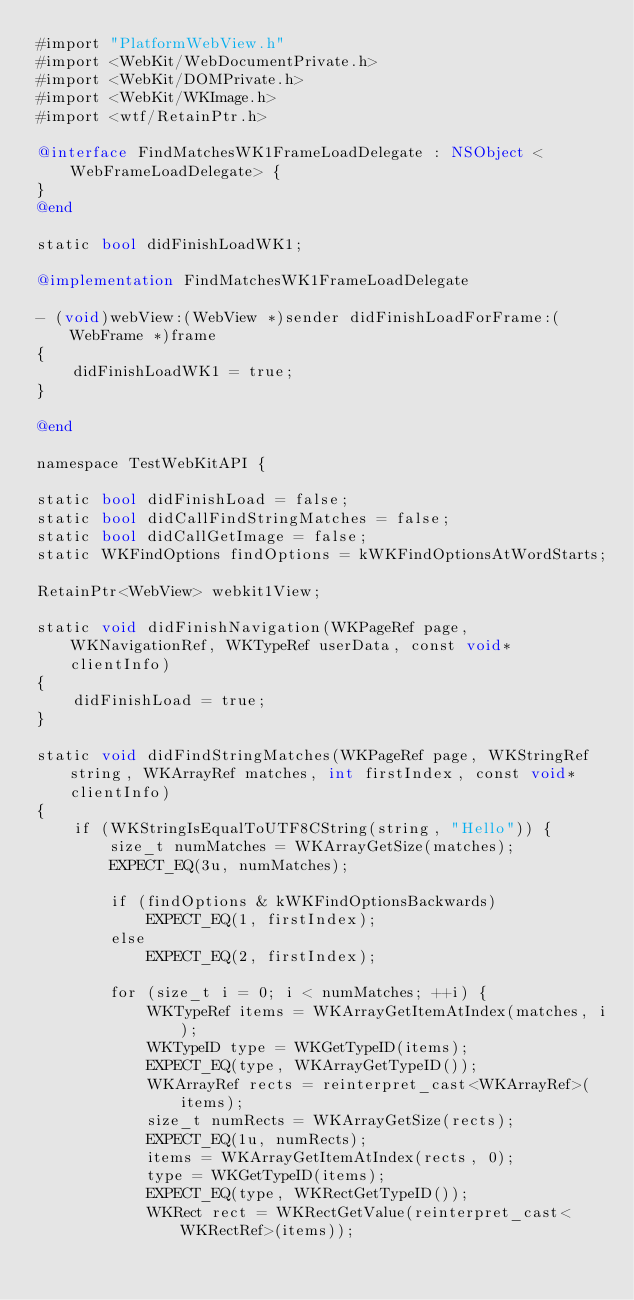<code> <loc_0><loc_0><loc_500><loc_500><_ObjectiveC_>#import "PlatformWebView.h"
#import <WebKit/WebDocumentPrivate.h>
#import <WebKit/DOMPrivate.h>
#import <WebKit/WKImage.h>
#import <wtf/RetainPtr.h>

@interface FindMatchesWK1FrameLoadDelegate : NSObject <WebFrameLoadDelegate> {
}
@end

static bool didFinishLoadWK1;

@implementation FindMatchesWK1FrameLoadDelegate

- (void)webView:(WebView *)sender didFinishLoadForFrame:(WebFrame *)frame
{
    didFinishLoadWK1 = true;
}

@end

namespace TestWebKitAPI {

static bool didFinishLoad = false;
static bool didCallFindStringMatches = false;
static bool didCallGetImage = false;
static WKFindOptions findOptions = kWKFindOptionsAtWordStarts;

RetainPtr<WebView> webkit1View;

static void didFinishNavigation(WKPageRef page, WKNavigationRef, WKTypeRef userData, const void* clientInfo)
{
    didFinishLoad = true;
}

static void didFindStringMatches(WKPageRef page, WKStringRef string, WKArrayRef matches, int firstIndex, const void* clientInfo)
{
    if (WKStringIsEqualToUTF8CString(string, "Hello")) {
        size_t numMatches = WKArrayGetSize(matches);
        EXPECT_EQ(3u, numMatches);

        if (findOptions & kWKFindOptionsBackwards)
            EXPECT_EQ(1, firstIndex);
        else
            EXPECT_EQ(2, firstIndex);

        for (size_t i = 0; i < numMatches; ++i) {
            WKTypeRef items = WKArrayGetItemAtIndex(matches, i);
            WKTypeID type = WKGetTypeID(items);
            EXPECT_EQ(type, WKArrayGetTypeID());
            WKArrayRef rects = reinterpret_cast<WKArrayRef>(items);
            size_t numRects = WKArrayGetSize(rects);
            EXPECT_EQ(1u, numRects);
            items = WKArrayGetItemAtIndex(rects, 0);
            type = WKGetTypeID(items);
            EXPECT_EQ(type, WKRectGetTypeID());
            WKRect rect = WKRectGetValue(reinterpret_cast<WKRectRef>(items));</code> 